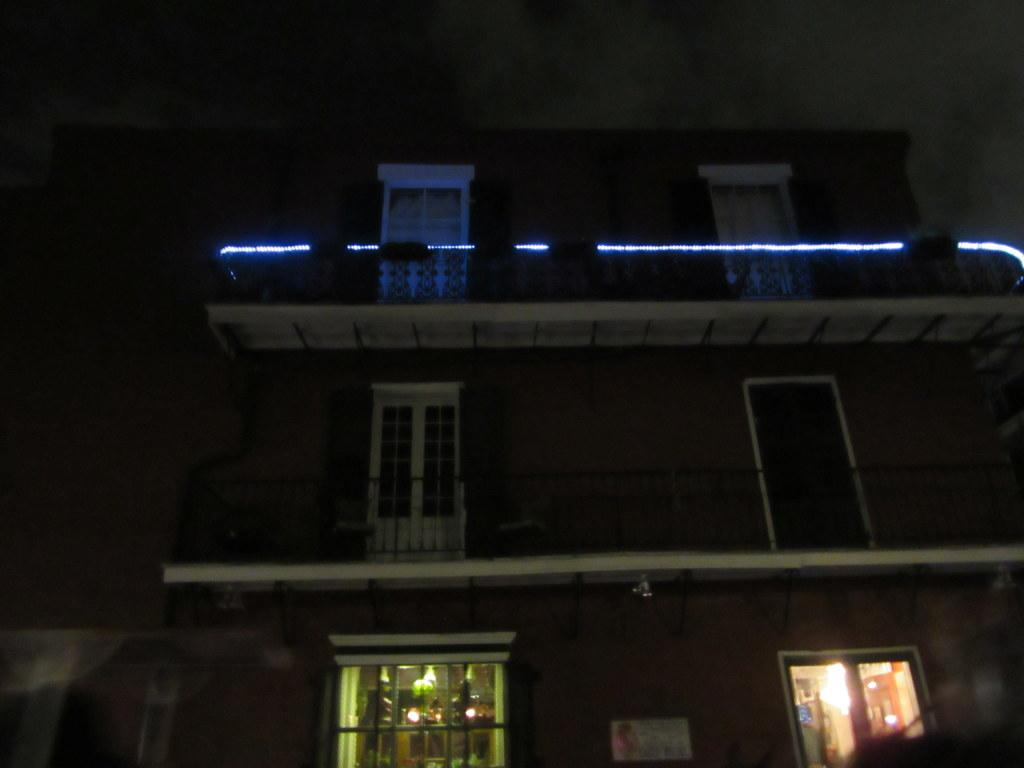What type of structure is present in the image? There is a building in the image. Where is the building located in relation to the image? The building is towards the bottom of the image. What feature of the building is mentioned in the facts? There are windows in the building. What other element can be seen in the image? There is a wall in the image. What else is visible in the image besides the building and wall? There are lights in the image. What part of the natural environment is visible in the image? The sky is visible towards the top of the image. What type of chain is holding the girl in the image? There is no girl or chain present in the image. What is the building made of in the image? The facts do not mention the material of the building, so we cannot determine if it is made of zinc or any other material. 